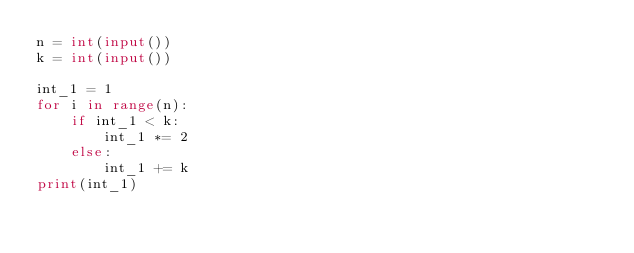Convert code to text. <code><loc_0><loc_0><loc_500><loc_500><_Python_>n = int(input())
k = int(input())

int_1 = 1
for i in range(n):
    if int_1 < k:
        int_1 *= 2
    else:
        int_1 += k
print(int_1)</code> 